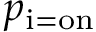Convert formula to latex. <formula><loc_0><loc_0><loc_500><loc_500>p _ { i = o n }</formula> 